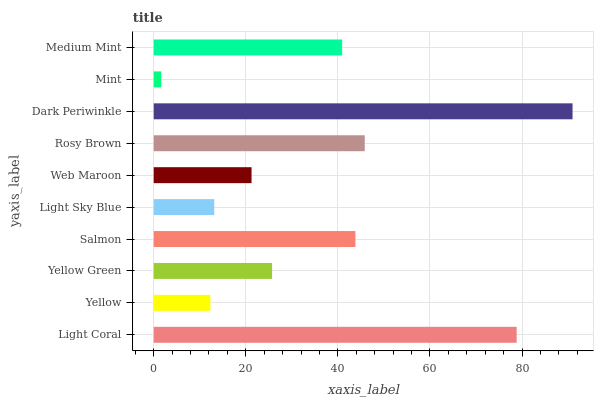Is Mint the minimum?
Answer yes or no. Yes. Is Dark Periwinkle the maximum?
Answer yes or no. Yes. Is Yellow the minimum?
Answer yes or no. No. Is Yellow the maximum?
Answer yes or no. No. Is Light Coral greater than Yellow?
Answer yes or no. Yes. Is Yellow less than Light Coral?
Answer yes or no. Yes. Is Yellow greater than Light Coral?
Answer yes or no. No. Is Light Coral less than Yellow?
Answer yes or no. No. Is Medium Mint the high median?
Answer yes or no. Yes. Is Yellow Green the low median?
Answer yes or no. Yes. Is Light Coral the high median?
Answer yes or no. No. Is Web Maroon the low median?
Answer yes or no. No. 